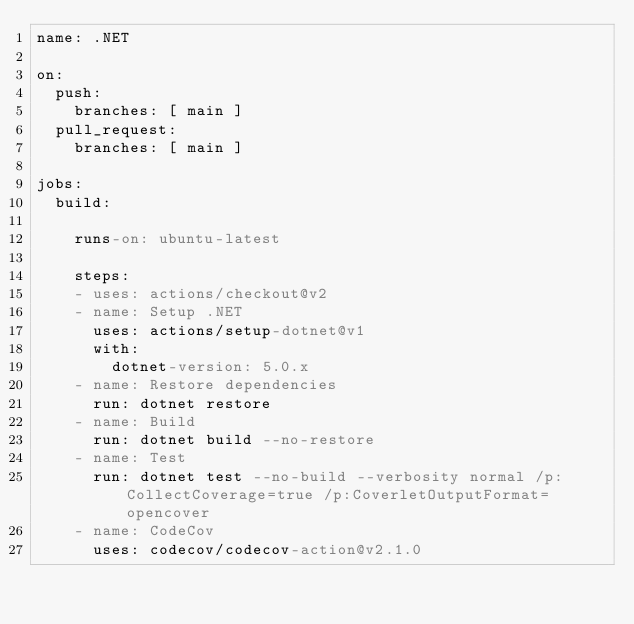Convert code to text. <code><loc_0><loc_0><loc_500><loc_500><_YAML_>name: .NET

on:
  push:
    branches: [ main ]
  pull_request:
    branches: [ main ]

jobs:
  build:

    runs-on: ubuntu-latest

    steps:
    - uses: actions/checkout@v2
    - name: Setup .NET
      uses: actions/setup-dotnet@v1
      with:
        dotnet-version: 5.0.x
    - name: Restore dependencies
      run: dotnet restore
    - name: Build
      run: dotnet build --no-restore
    - name: Test
      run: dotnet test --no-build --verbosity normal /p:CollectCoverage=true /p:CoverletOutputFormat=opencover
    - name: CodeCov
      uses: codecov/codecov-action@v2.1.0
</code> 